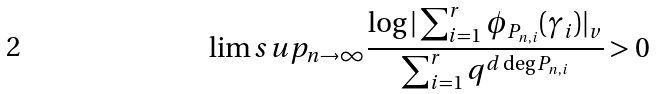<formula> <loc_0><loc_0><loc_500><loc_500>\lim s u p _ { n \to \infty } \frac { \log | \sum _ { i = 1 } ^ { r } \phi _ { P _ { n , i } } ( \gamma _ { i } ) | _ { v } } { \sum _ { i = 1 } ^ { r } q ^ { d \deg P _ { n , i } } } > 0</formula> 